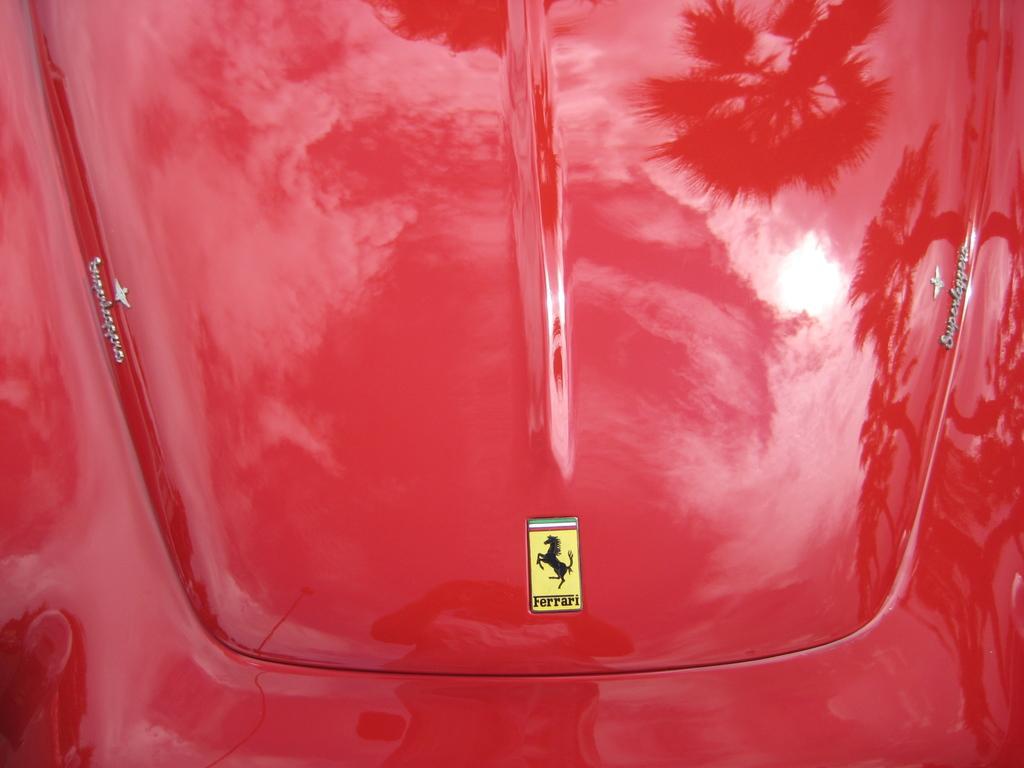In one or two sentences, can you explain what this image depicts? In this picture we can see red color vehicle, on which we can see logo. 